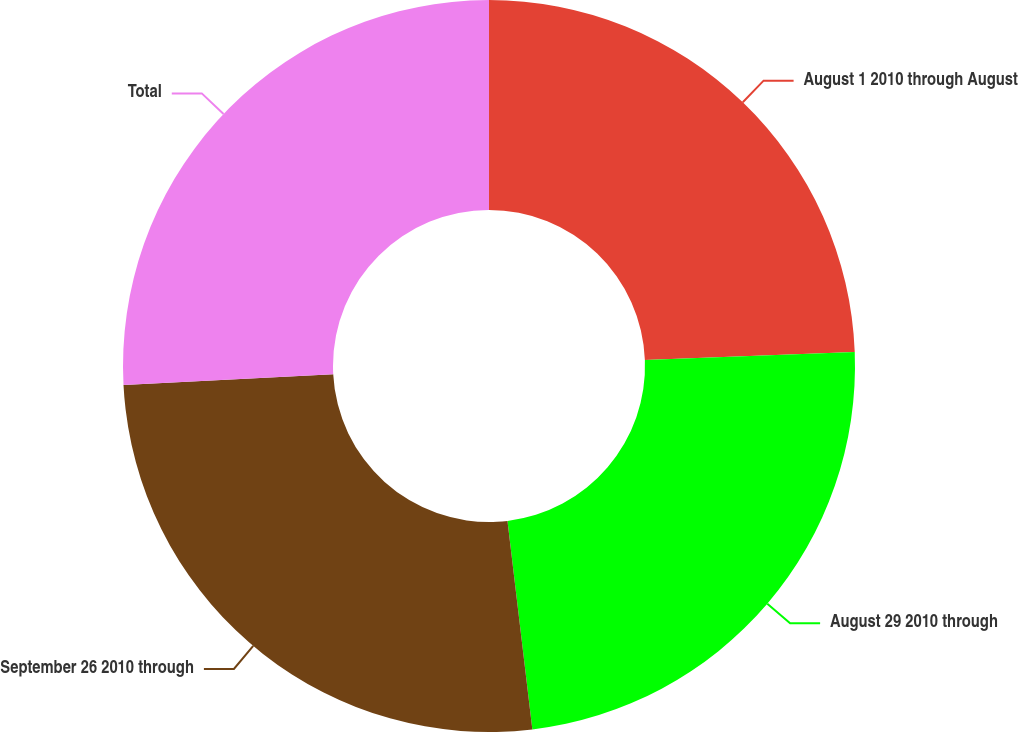Convert chart. <chart><loc_0><loc_0><loc_500><loc_500><pie_chart><fcel>August 1 2010 through August<fcel>August 29 2010 through<fcel>September 26 2010 through<fcel>Total<nl><fcel>24.39%<fcel>23.72%<fcel>26.06%<fcel>25.83%<nl></chart> 